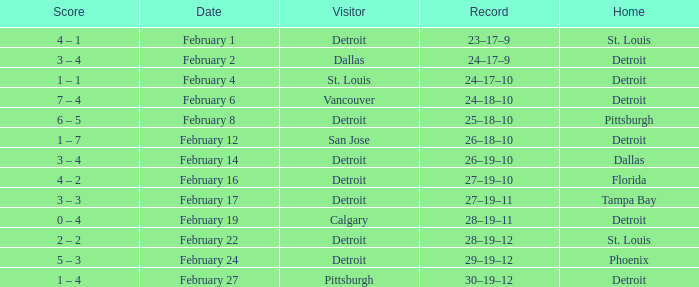What was their record on February 24? 29–19–12. 